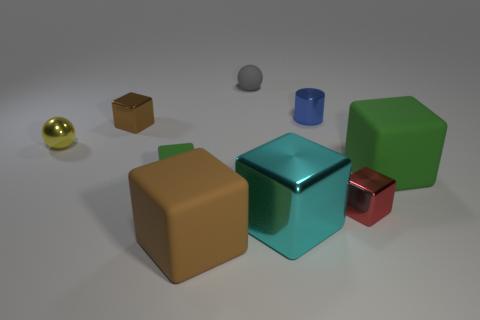Subtract all brown blocks. How many blocks are left? 4 Subtract all red cubes. How many cubes are left? 5 Subtract 1 cylinders. How many cylinders are left? 0 Subtract all balls. How many objects are left? 7 Subtract all red balls. How many brown cubes are left? 2 Subtract all big objects. Subtract all small yellow shiny things. How many objects are left? 5 Add 3 red objects. How many red objects are left? 4 Add 1 tiny green blocks. How many tiny green blocks exist? 2 Subtract 0 cyan cylinders. How many objects are left? 9 Subtract all gray spheres. Subtract all gray blocks. How many spheres are left? 1 